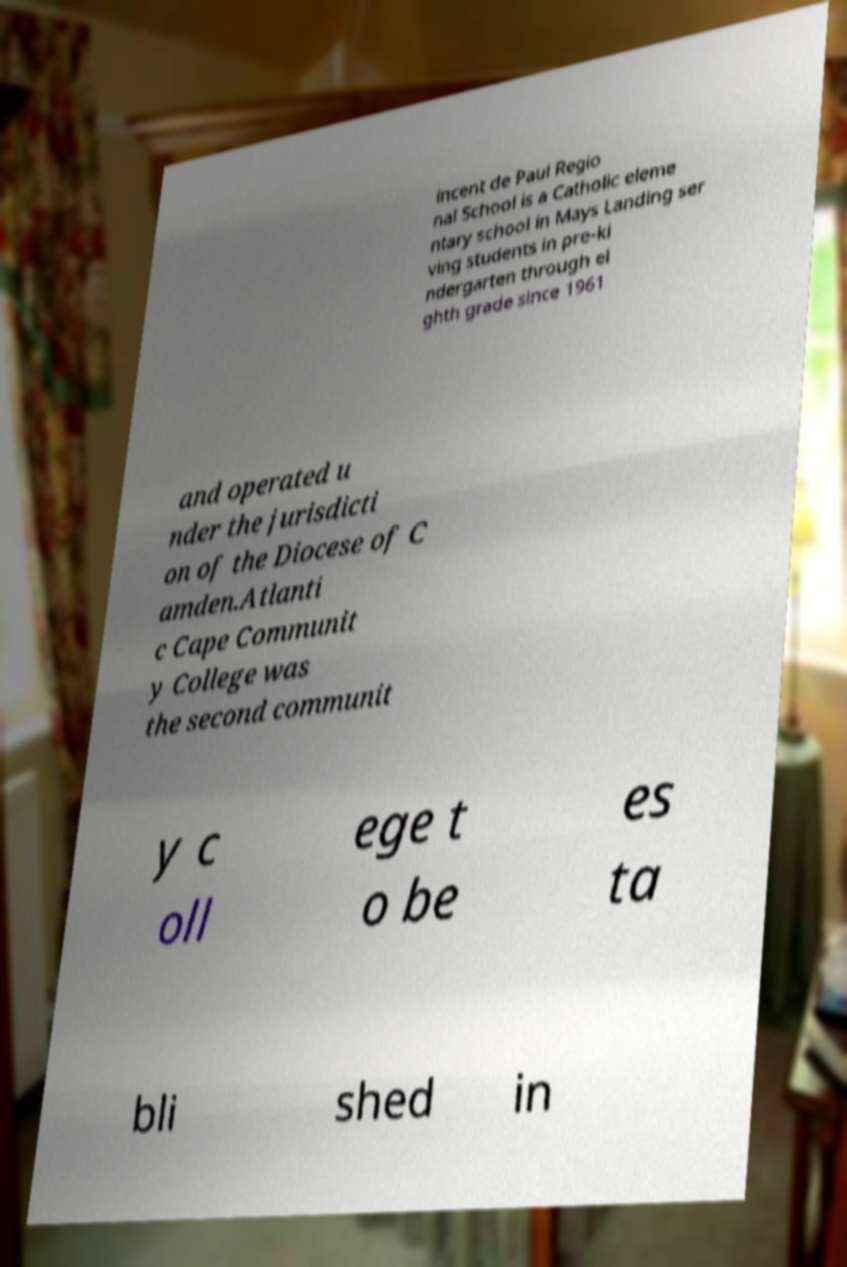Could you extract and type out the text from this image? incent de Paul Regio nal School is a Catholic eleme ntary school in Mays Landing ser ving students in pre-ki ndergarten through ei ghth grade since 1961 and operated u nder the jurisdicti on of the Diocese of C amden.Atlanti c Cape Communit y College was the second communit y c oll ege t o be es ta bli shed in 